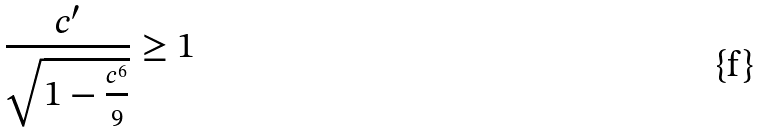<formula> <loc_0><loc_0><loc_500><loc_500>\frac { c ^ { \prime } } { \sqrt { 1 - \frac { c ^ { 6 } } { 9 } } } \geq 1</formula> 